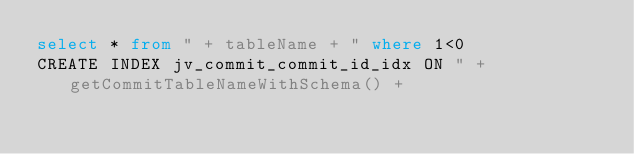Convert code to text. <code><loc_0><loc_0><loc_500><loc_500><_SQL_>select * from " + tableName + " where 1<0
CREATE INDEX jv_commit_commit_id_idx ON " + getCommitTableNameWithSchema() + 
</code> 